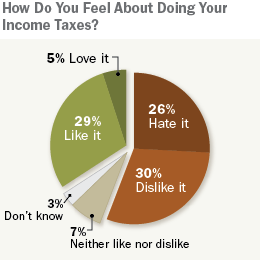Indicate a few pertinent items in this graphic. What is the difference between the largest and smallest segments in the number 27? The value of the "Like it" segment is 29. 